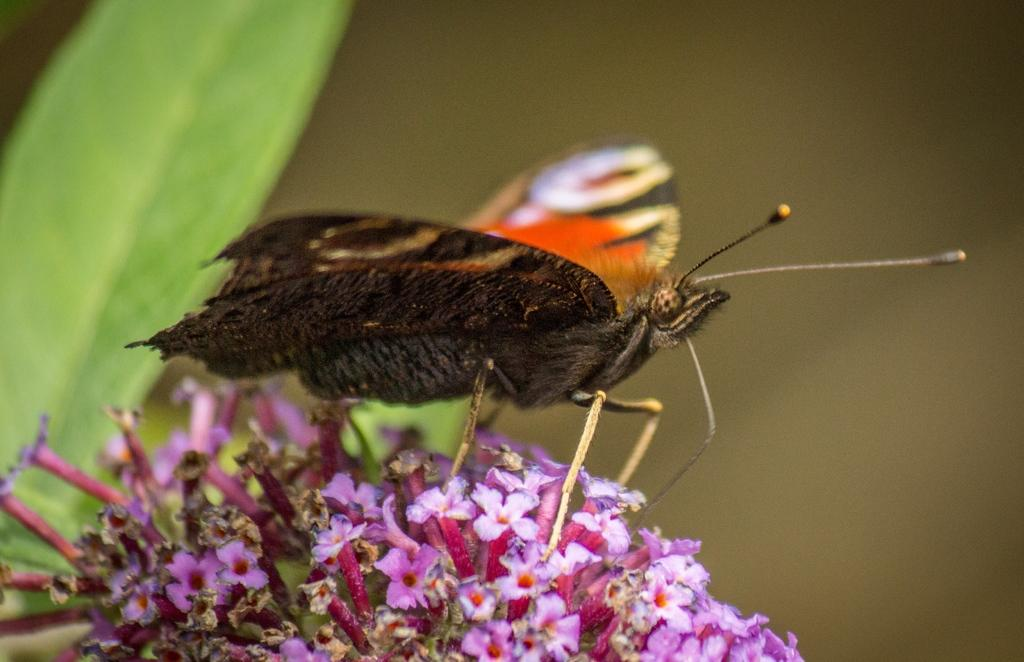What is the main subject of the image? There is a butterfly in the image. Where is the butterfly located? The butterfly is on flowers. What can be observed about the background of the image? The background of the image is blurred. What other elements are present in the image besides the butterfly and flowers? Leaves are present in the image. What type of wood is the butterfly using to cover its mouth in the image? There is no wood or mouth present in the image; it features a butterfly on flowers with leaves in the background. 